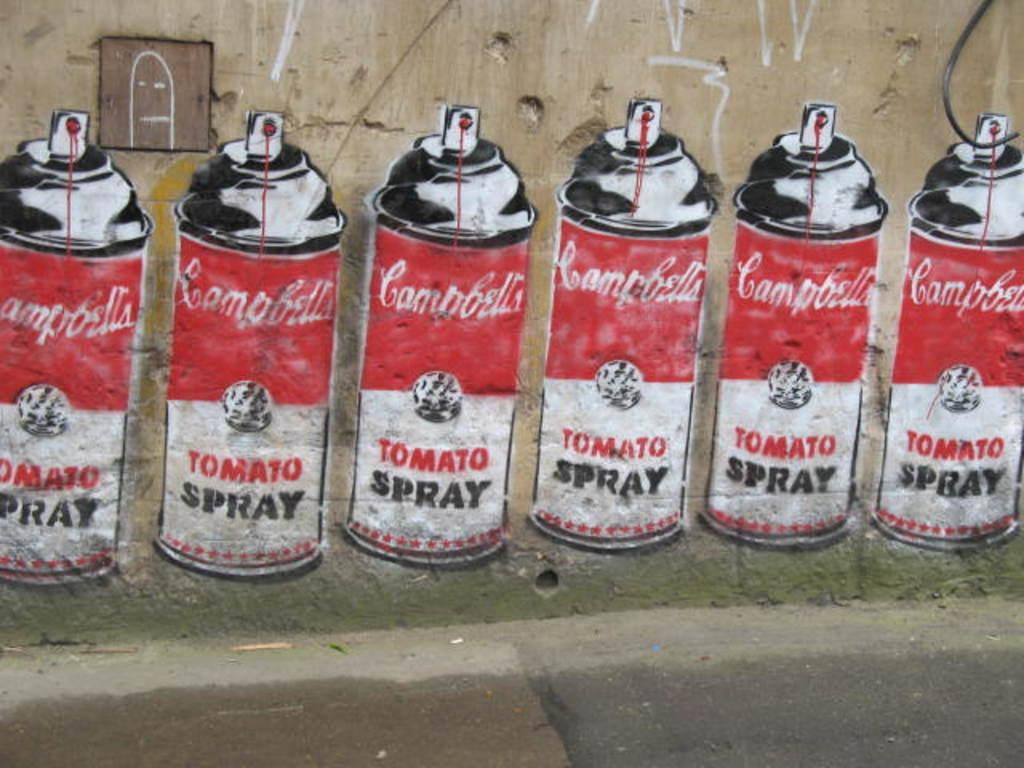<image>
Render a clear and concise summary of the photo. A mural featuring several spray paint cans with Campbell's tomato spray labels is painted on a wall. 